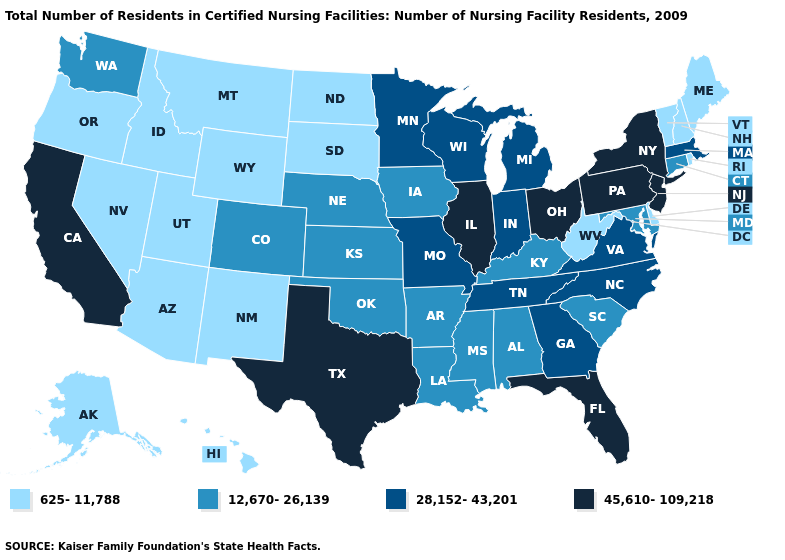Which states have the lowest value in the USA?
Give a very brief answer. Alaska, Arizona, Delaware, Hawaii, Idaho, Maine, Montana, Nevada, New Hampshire, New Mexico, North Dakota, Oregon, Rhode Island, South Dakota, Utah, Vermont, West Virginia, Wyoming. What is the value of Utah?
Quick response, please. 625-11,788. Name the states that have a value in the range 12,670-26,139?
Be succinct. Alabama, Arkansas, Colorado, Connecticut, Iowa, Kansas, Kentucky, Louisiana, Maryland, Mississippi, Nebraska, Oklahoma, South Carolina, Washington. Does Vermont have the lowest value in the Northeast?
Keep it brief. Yes. What is the highest value in the USA?
Write a very short answer. 45,610-109,218. Does Massachusetts have a lower value than Ohio?
Concise answer only. Yes. Does Alabama have a higher value than South Dakota?
Quick response, please. Yes. What is the value of Missouri?
Quick response, please. 28,152-43,201. Name the states that have a value in the range 625-11,788?
Write a very short answer. Alaska, Arizona, Delaware, Hawaii, Idaho, Maine, Montana, Nevada, New Hampshire, New Mexico, North Dakota, Oregon, Rhode Island, South Dakota, Utah, Vermont, West Virginia, Wyoming. What is the value of North Carolina?
Be succinct. 28,152-43,201. What is the value of Wyoming?
Be succinct. 625-11,788. What is the value of Arizona?
Concise answer only. 625-11,788. Which states have the lowest value in the USA?
Quick response, please. Alaska, Arizona, Delaware, Hawaii, Idaho, Maine, Montana, Nevada, New Hampshire, New Mexico, North Dakota, Oregon, Rhode Island, South Dakota, Utah, Vermont, West Virginia, Wyoming. Does West Virginia have the same value as New Hampshire?
Keep it brief. Yes. What is the value of Alabama?
Write a very short answer. 12,670-26,139. 